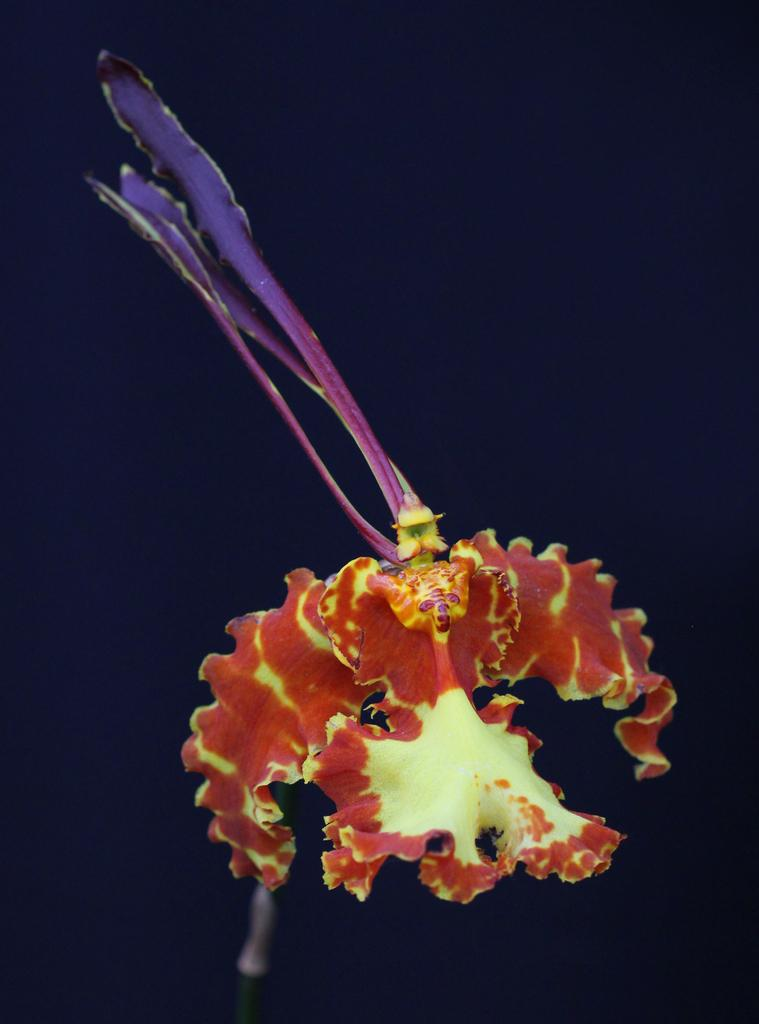What is the main subject of the picture? The main subject of the picture is a flower. Can you describe the colors of the flower? The flower has orange and yellow colors, as well as some petals with blue and violet colors. How much tax is being paid on the flower in the image? There is no mention of tax in the image, and the flower is not a subject that would be taxed. 